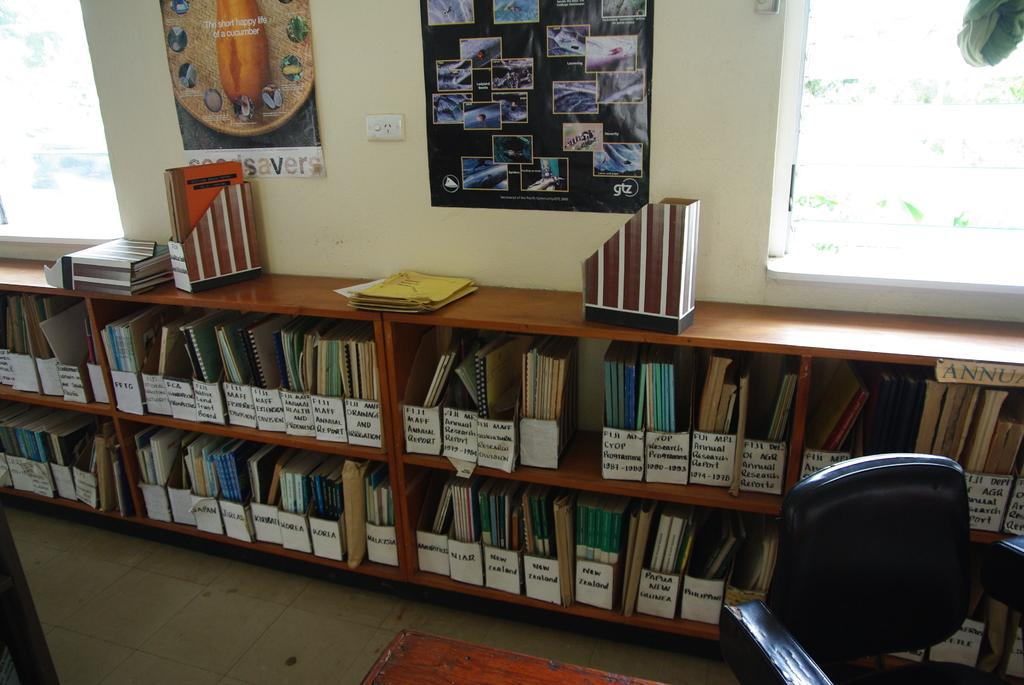<image>
Relay a brief, clear account of the picture shown. A number of books aligned on bookshelfs including some that are Annual Reports. 